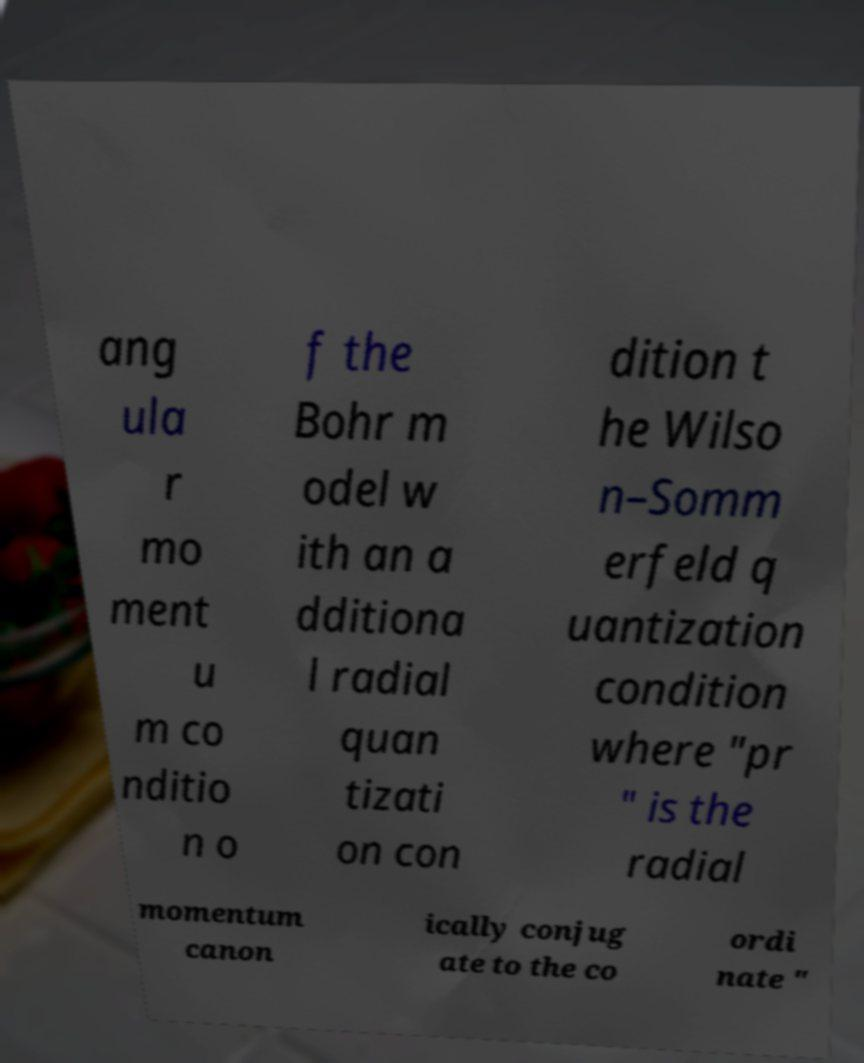Can you read and provide the text displayed in the image?This photo seems to have some interesting text. Can you extract and type it out for me? ang ula r mo ment u m co nditio n o f the Bohr m odel w ith an a dditiona l radial quan tizati on con dition t he Wilso n–Somm erfeld q uantization condition where "pr " is the radial momentum canon ically conjug ate to the co ordi nate " 